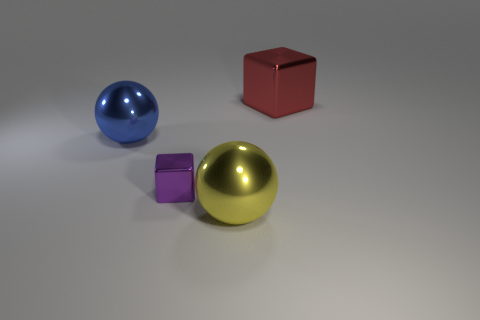The metal cube that is the same size as the yellow thing is what color?
Keep it short and to the point. Red. Are there any metallic objects behind the yellow object that is right of the big blue shiny ball?
Offer a very short reply. Yes. What number of cylinders are yellow metallic things or big metal objects?
Keep it short and to the point. 0. There is a object that is on the right side of the ball right of the shiny sphere that is behind the big yellow metallic sphere; what is its size?
Keep it short and to the point. Large. There is a big blue metal sphere; are there any shiny objects in front of it?
Provide a succinct answer. Yes. What number of objects are large objects in front of the blue ball or big blue spheres?
Make the answer very short. 2. There is a blue sphere that is the same material as the tiny purple cube; what size is it?
Offer a terse response. Large. Does the yellow object have the same size as the cube left of the big block?
Provide a short and direct response. No. There is a metallic object that is right of the purple metallic object and behind the small purple block; what is its color?
Ensure brevity in your answer.  Red. What number of objects are metal blocks in front of the blue metal ball or large metal objects that are to the left of the purple thing?
Your answer should be compact. 2. 